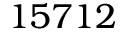<formula> <loc_0><loc_0><loc_500><loc_500>1 5 7 1 2</formula> 